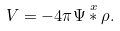<formula> <loc_0><loc_0><loc_500><loc_500>V = - 4 \pi \Psi \overset { x } { \ast } \rho .</formula> 